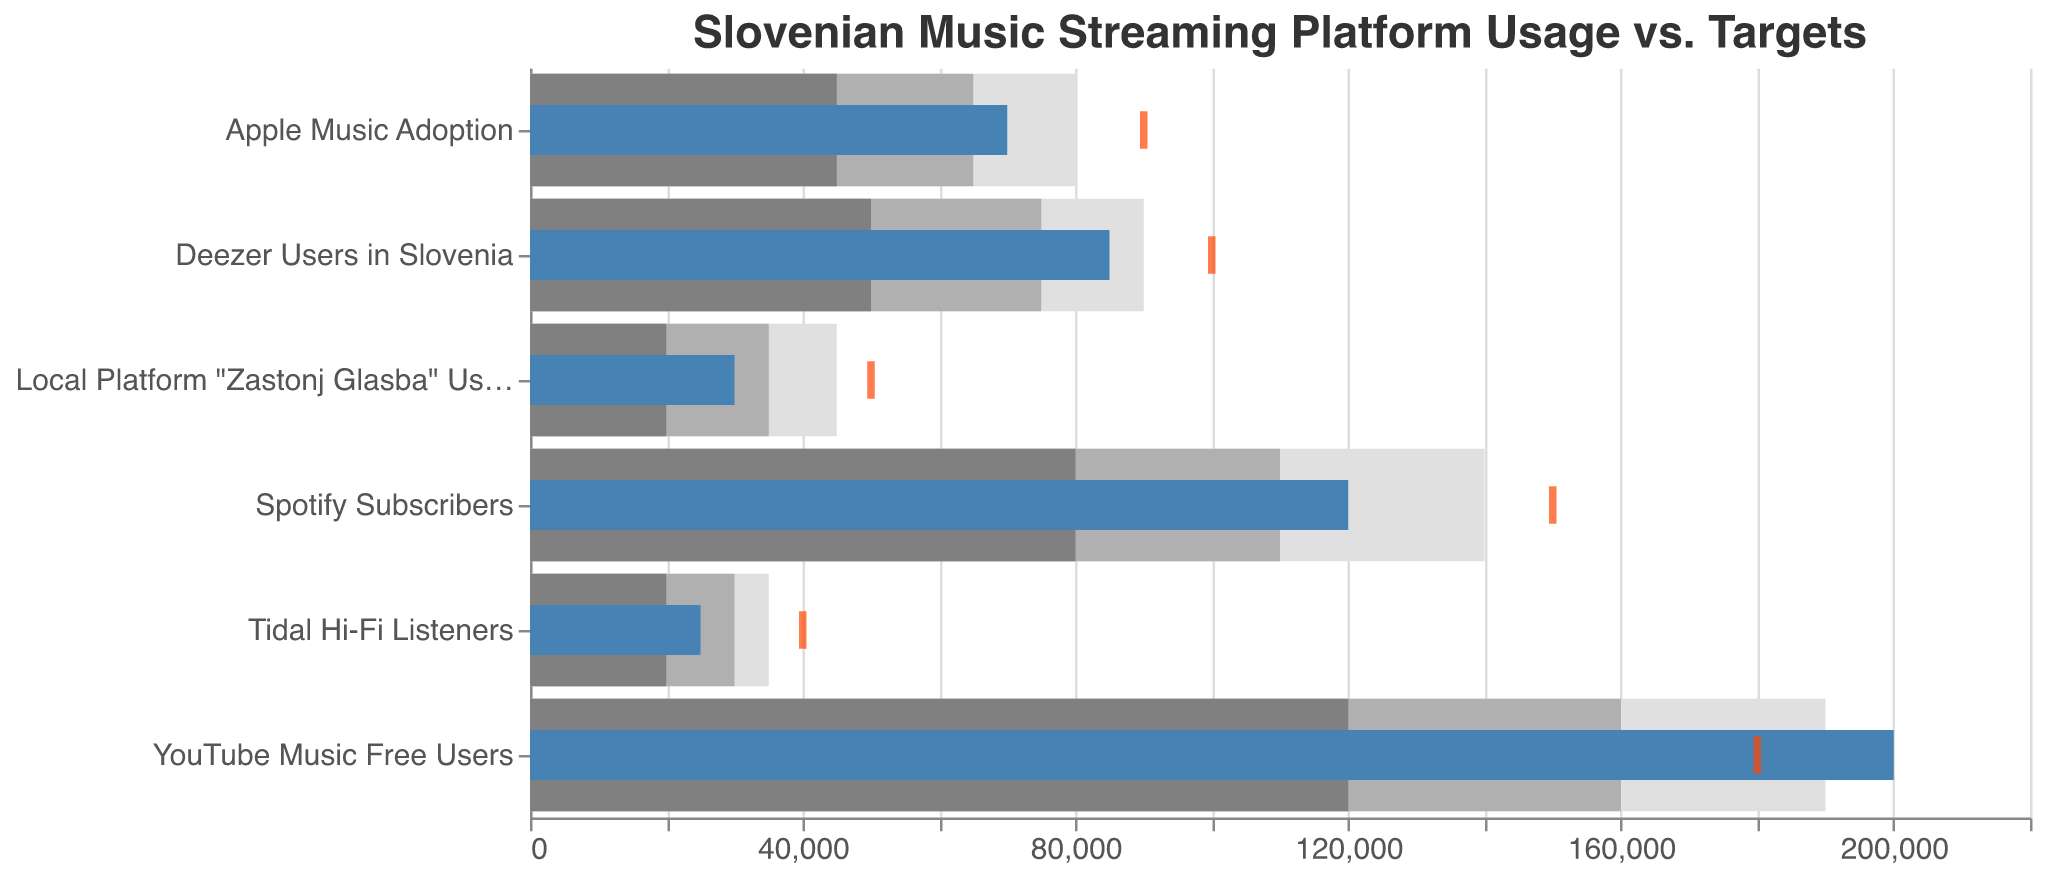What is the target number of users for Deezer in Slovenia? The tick mark for Deezer identifies the target number of users. The chart shows the target for Deezer is 100,000 users.
Answer: 100,000 How many actual YouTube Music free users are there in Slovenia? The value represented by the blue bar for YouTube Music free users shows the actual number of users. This bar extends to 200,000 users.
Answer: 200,000 Which music platform has the highest actual user count? Compare the lengths of the blue bars for each platform. The longest blue bar corresponds to YouTube Music free users, which has 200,000 users, the highest actual user count in the chart.
Answer: YouTube Music free users How does the actual number of Deezer users compare to its target? Compare the length of the blue bar and the position of the tick mark for Deezer. The actual number of users (85,000) does not meet the target (100,000).
Answer: Below target What is the difference between the actual and target values for Tidal Hi-Fi listeners? Subtract the actual amount (25,000) from the target amount (40,000) for Tidal Hi-Fi listeners. The difference is 40,000 - 25,000 = 15,000 users.
Answer: 15,000 Which platforms achieved their target user numbers? Check whether the blue bar’s length (actual users) reaches or exceeds the tick mark (target users). Only YouTube Music free users (actual 200,000; target 180,000) meets or exceeds its target.
Answer: YouTube Music free users For which platform is the target number of users the highest? Compare the position of the tick marks for each platform. The highest tick mark corresponds to Spotify Subscribers with a target of 150,000 users.
Answer: Spotify Subscribers What is the actual number of users for the local platform "Zastonj Glasba"? Identify the length of the blue bar for "Zastonj Glasba". The bar extends to 30,000 users.
Answer: 30,000 Is the actual number of Apple Music users within its expected range3? Compare the length of the blue bar to the range3 bar for Apple Music. The actual number of 70,000 falls within the range3 (80,000), which spans from 0 to 90,000.
Answer: Yes Which platform’s users most exceed their range2? Find the blue bar that most exceeds its corresponding grey range2 bar. The blue bar for YouTube Music free users (200,000) most significantly exceeds its range2 (160,000).
Answer: YouTube Music free users 